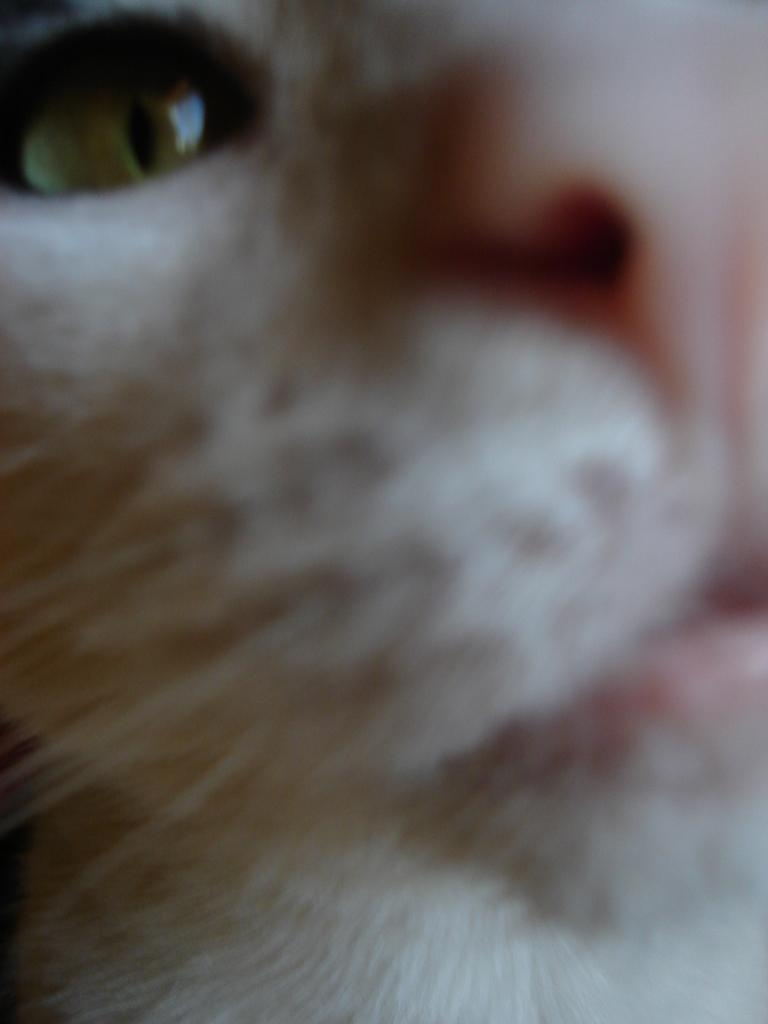What type of animal is in the picture? There is a white color cat in the picture. What is the cat doing in the picture? The cat is looking into the camera. What shape is the egg in the picture? There is no egg present in the picture; it features a white color cat. What type of system is being used to capture the image? The facts provided do not mention any specific system being used to capture the image, so it cannot be determined from the information given. 